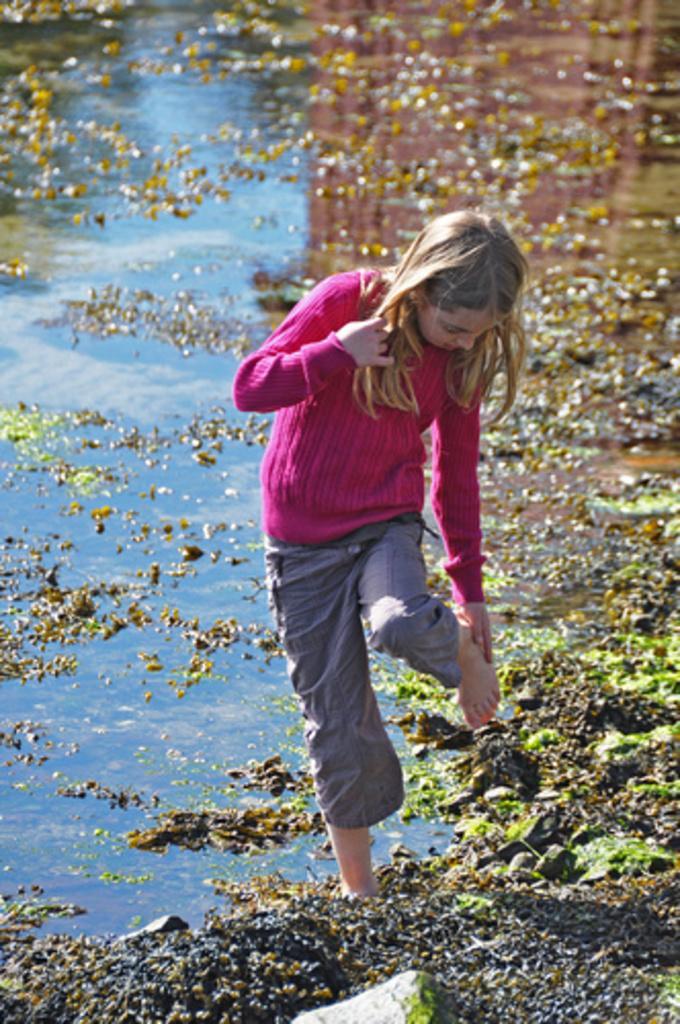Could you give a brief overview of what you see in this image? In this image there is a girl who is standing in the water by keeping one leg in water and one leg upwards. In the background there is water in which there are leaves and stones. The girl is touching the leg with her hand. 